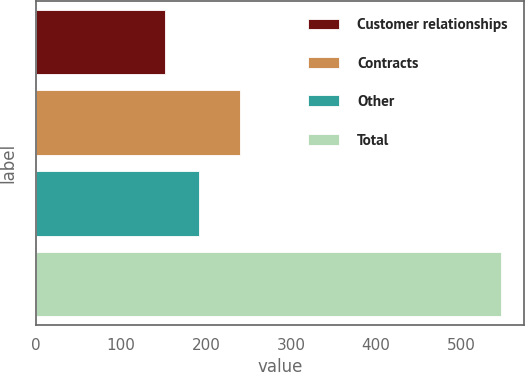Convert chart. <chart><loc_0><loc_0><loc_500><loc_500><bar_chart><fcel>Customer relationships<fcel>Contracts<fcel>Other<fcel>Total<nl><fcel>152<fcel>240<fcel>191.5<fcel>547<nl></chart> 